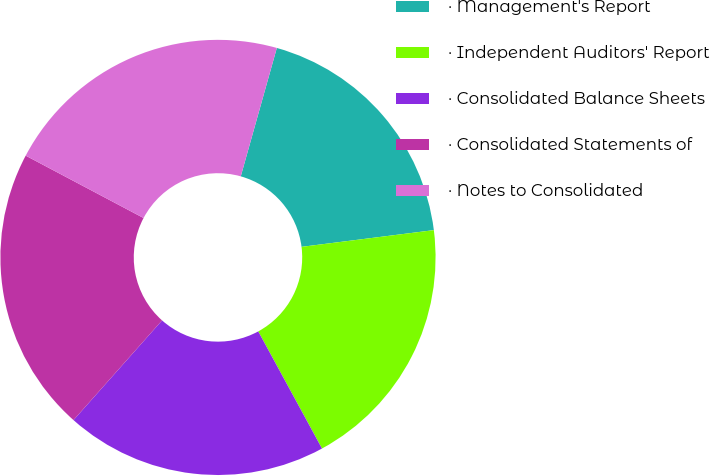Convert chart to OTSL. <chart><loc_0><loc_0><loc_500><loc_500><pie_chart><fcel>· Management's Report<fcel>· Independent Auditors' Report<fcel>· Consolidated Balance Sheets<fcel>· Consolidated Statements of<fcel>· Notes to Consolidated<nl><fcel>18.64%<fcel>19.07%<fcel>19.49%<fcel>21.19%<fcel>21.61%<nl></chart> 